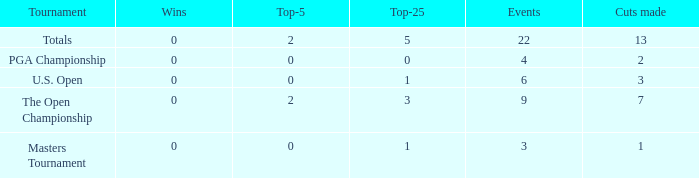What is the average number of cuts made for events with under 4 entries and more than 0 wins? None. 